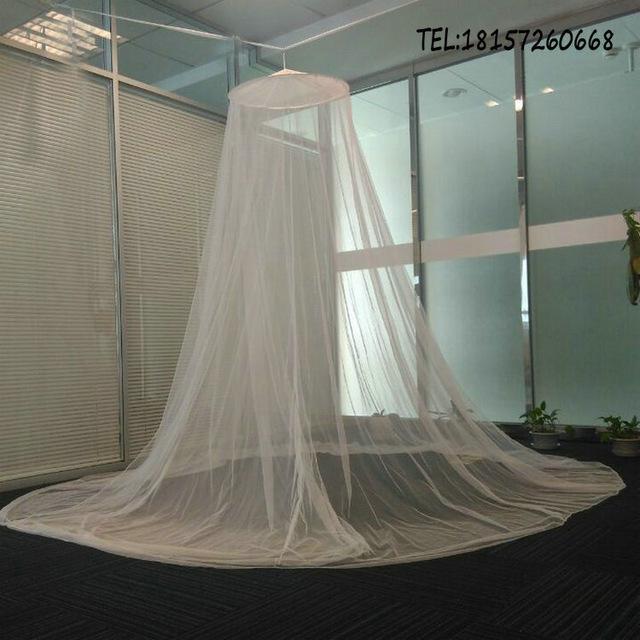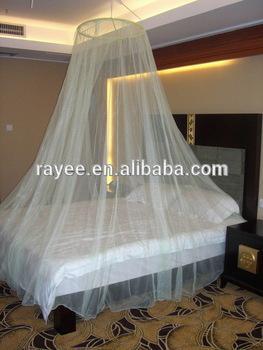The first image is the image on the left, the second image is the image on the right. Assess this claim about the two images: "Each image shows a gauzy canopy that drapes from a round shape suspended from the ceiling, and the right image features an aqua canopy with a ruffle around the top.". Correct or not? Answer yes or no. No. The first image is the image on the left, the second image is the image on the right. For the images shown, is this caption "The left and right image contains the same number of canopies with at least one green one." true? Answer yes or no. No. 